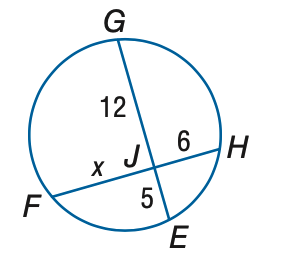Answer the mathemtical geometry problem and directly provide the correct option letter.
Question: Find x to the nearest tenth.
Choices: A: 7 B: 8 C: 9 D: 10 D 